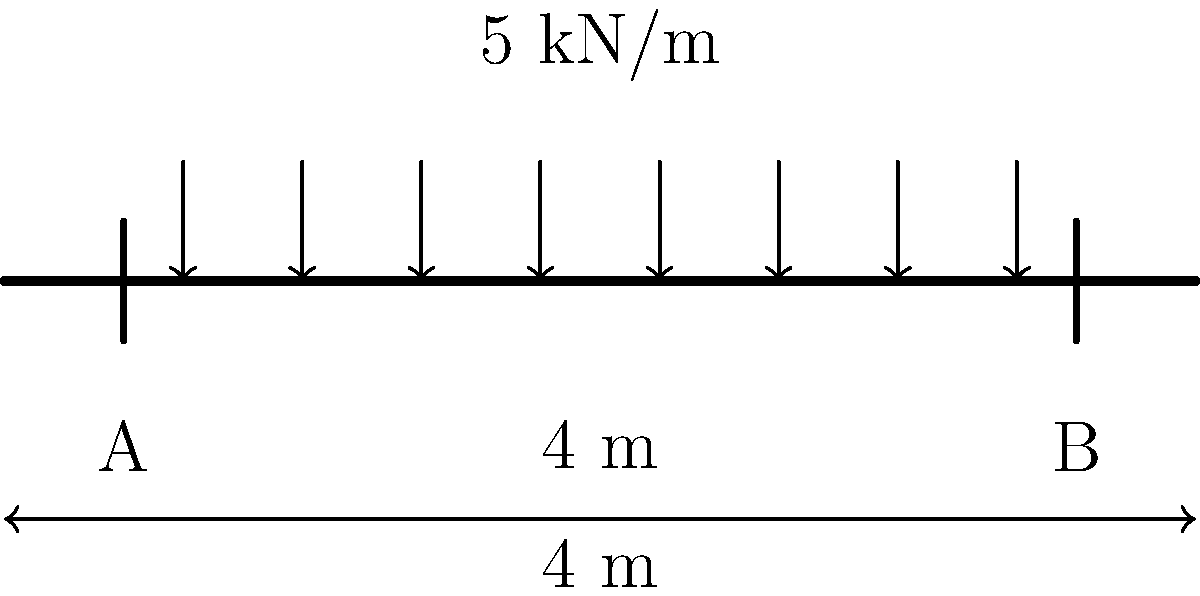As a young athlete who composes motivational songs, you're working on a project to renovate your team's training facility. You need to calculate the maximum bending moment for a simple beam that will support equipment in the new weight room. The beam is 4 meters long, supported at both ends, and carries a uniformly distributed load of 5 kN/m along its entire length. Calculate the maximum bending moment in the beam. Let's approach this step-by-step:

1) For a simply supported beam with a uniformly distributed load, the maximum bending moment occurs at the center of the beam.

2) The formula for the maximum bending moment (M_max) in this case is:

   $$M_{max} = \frac{wL^2}{8}$$

   Where:
   w = uniformly distributed load
   L = length of the beam

3) We are given:
   w = 5 kN/m
   L = 4 m

4) Let's substitute these values into the formula:

   $$M_{max} = \frac{5 \text{ kN/m} \times (4 \text{ m})^2}{8}$$

5) Simplify:
   $$M_{max} = \frac{5 \times 16}{8} \text{ kN·m}$$

6) Calculate:
   $$M_{max} = 10 \text{ kN·m}$$

Thus, the maximum bending moment in the beam is 10 kN·m.
Answer: 10 kN·m 